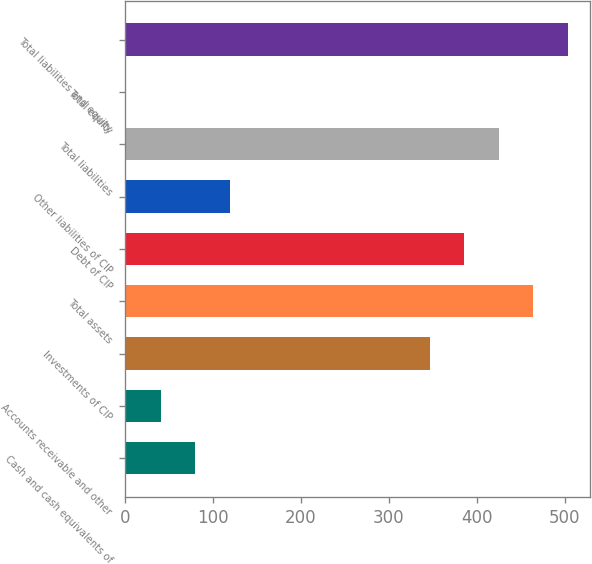<chart> <loc_0><loc_0><loc_500><loc_500><bar_chart><fcel>Cash and cash equivalents of<fcel>Accounts receivable and other<fcel>Investments of CIP<fcel>Total assets<fcel>Debt of CIP<fcel>Other liabilities of CIP<fcel>Total liabilities<fcel>Total equity<fcel>Total liabilities and equity<nl><fcel>79.72<fcel>40.36<fcel>346.5<fcel>464.58<fcel>385.86<fcel>119.08<fcel>425.22<fcel>1<fcel>503.94<nl></chart> 